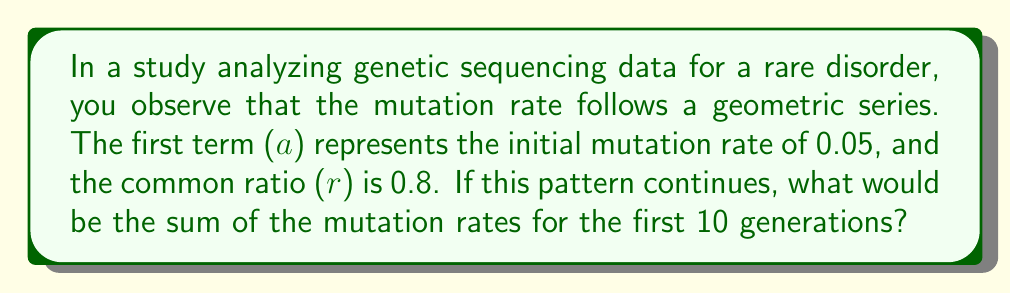Teach me how to tackle this problem. To solve this problem, we need to use the formula for the sum of a geometric series:

$$ S_n = \frac{a(1-r^n)}{1-r} $$

Where:
$S_n$ is the sum of the first n terms
$a$ is the first term
$r$ is the common ratio
$n$ is the number of terms

Given:
$a = 0.05$ (initial mutation rate)
$r = 0.8$ (common ratio)
$n = 10$ (number of generations)

Let's substitute these values into the formula:

$$ S_{10} = \frac{0.05(1-0.8^{10})}{1-0.8} $$

Now, let's solve step by step:

1) First, calculate $0.8^{10}$:
   $0.8^{10} \approx 0.1074$

2) Substitute this value:
   $$ S_{10} = \frac{0.05(1-0.1074)}{1-0.8} = \frac{0.05(0.8926)}{0.2} $$

3) Simplify the numerator:
   $$ S_{10} = \frac{0.044630}{0.2} $$

4) Divide:
   $$ S_{10} = 0.22315 $$

Therefore, the sum of the mutation rates for the first 10 generations is approximately 0.22315.
Answer: 0.22315 